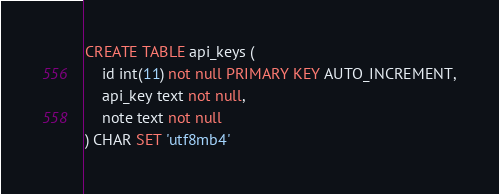Convert code to text. <code><loc_0><loc_0><loc_500><loc_500><_SQL_>CREATE TABLE api_keys (
    id int(11) not null PRIMARY KEY AUTO_INCREMENT,
    api_key text not null,
    note text not null
) CHAR SET 'utf8mb4'</code> 